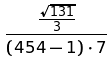Convert formula to latex. <formula><loc_0><loc_0><loc_500><loc_500>\frac { \frac { \sqrt { 1 3 1 } } { 3 } } { ( 4 5 4 - 1 ) \cdot 7 }</formula> 